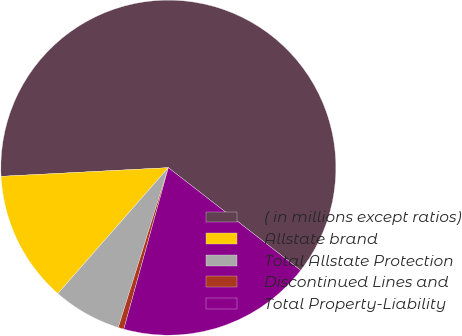Convert chart to OTSL. <chart><loc_0><loc_0><loc_500><loc_500><pie_chart><fcel>( in millions except ratios)<fcel>Allstate brand<fcel>Total Allstate Protection<fcel>Discontinued Lines and<fcel>Total Property-Liability<nl><fcel>61.33%<fcel>12.71%<fcel>6.63%<fcel>0.55%<fcel>18.78%<nl></chart> 